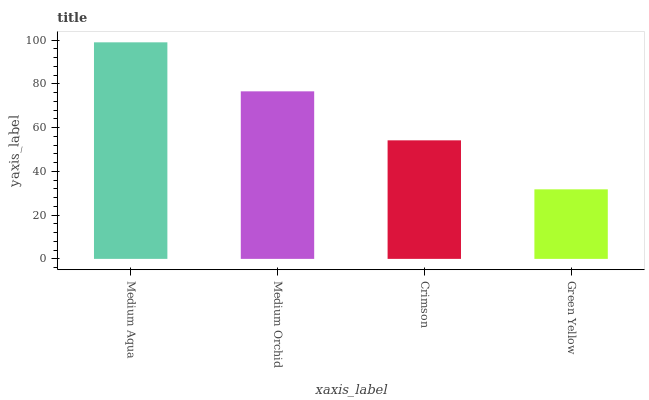Is Green Yellow the minimum?
Answer yes or no. Yes. Is Medium Aqua the maximum?
Answer yes or no. Yes. Is Medium Orchid the minimum?
Answer yes or no. No. Is Medium Orchid the maximum?
Answer yes or no. No. Is Medium Aqua greater than Medium Orchid?
Answer yes or no. Yes. Is Medium Orchid less than Medium Aqua?
Answer yes or no. Yes. Is Medium Orchid greater than Medium Aqua?
Answer yes or no. No. Is Medium Aqua less than Medium Orchid?
Answer yes or no. No. Is Medium Orchid the high median?
Answer yes or no. Yes. Is Crimson the low median?
Answer yes or no. Yes. Is Medium Aqua the high median?
Answer yes or no. No. Is Medium Orchid the low median?
Answer yes or no. No. 